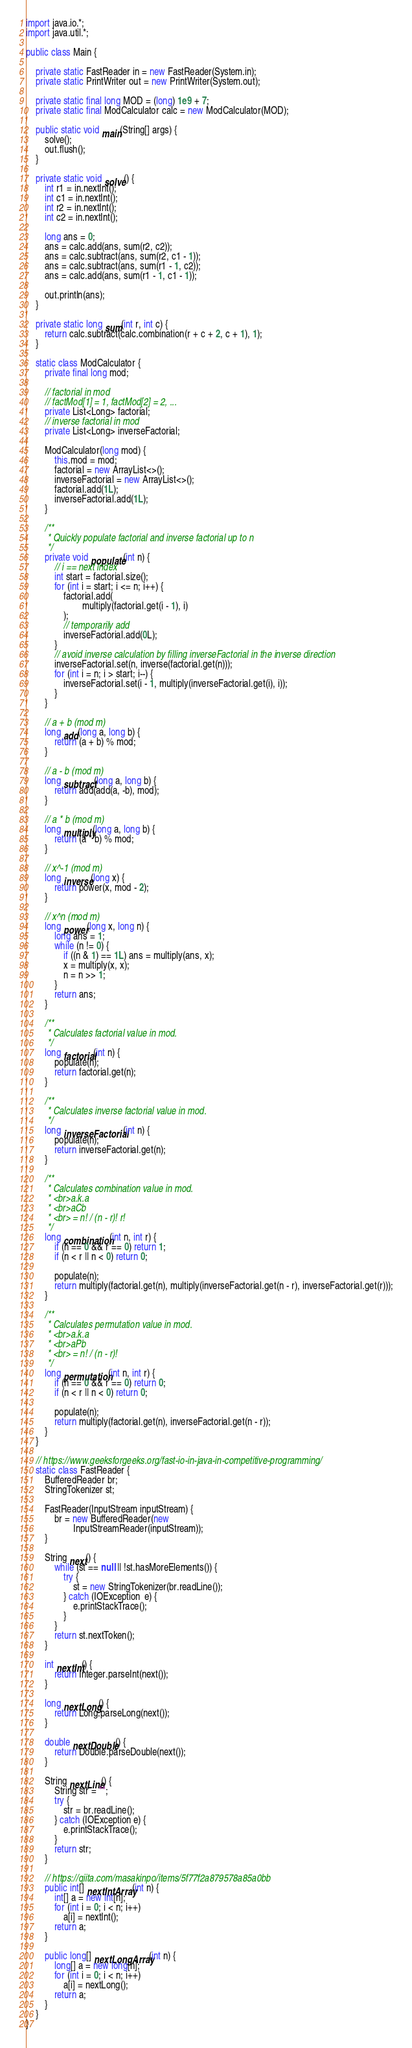Convert code to text. <code><loc_0><loc_0><loc_500><loc_500><_Java_>import java.io.*;
import java.util.*;

public class Main {

    private static FastReader in = new FastReader(System.in);
    private static PrintWriter out = new PrintWriter(System.out);

    private static final long MOD = (long) 1e9 + 7;
    private static final ModCalculator calc = new ModCalculator(MOD);

    public static void main(String[] args) {
        solve();
        out.flush();
    }

    private static void solve() {
        int r1 = in.nextInt();
        int c1 = in.nextInt();
        int r2 = in.nextInt();
        int c2 = in.nextInt();

        long ans = 0;
        ans = calc.add(ans, sum(r2, c2));
        ans = calc.subtract(ans, sum(r2, c1 - 1));
        ans = calc.subtract(ans, sum(r1 - 1, c2));
        ans = calc.add(ans, sum(r1 - 1, c1 - 1));

        out.println(ans);
    }

    private static long sum(int r, int c) {
        return calc.subtract(calc.combination(r + c + 2, c + 1), 1);
    }

    static class ModCalculator {
        private final long mod;

        // factorial in mod
        // factMod[1] = 1, factMod[2] = 2, ...
        private List<Long> factorial;
        // inverse factorial in mod
        private List<Long> inverseFactorial;

        ModCalculator(long mod) {
            this.mod = mod;
            factorial = new ArrayList<>();
            inverseFactorial = new ArrayList<>();
            factorial.add(1L);
            inverseFactorial.add(1L);
        }

        /**
         * Quickly populate factorial and inverse factorial up to n
         */
        private void populate(int n) {
            // i == next index
            int start = factorial.size();
            for (int i = start; i <= n; i++) {
                factorial.add(
                        multiply(factorial.get(i - 1), i)
                );
                // temporarily add
                inverseFactorial.add(0L);
            }
            // avoid inverse calculation by filling inverseFactorial in the inverse direction
            inverseFactorial.set(n, inverse(factorial.get(n)));
            for (int i = n; i > start; i--) {
                inverseFactorial.set(i - 1, multiply(inverseFactorial.get(i), i));
            }
        }

        // a + b (mod m)
        long add(long a, long b) {
            return (a + b) % mod;
        }

        // a - b (mod m)
        long subtract(long a, long b) {
            return add(add(a, -b), mod);
        }

        // a * b (mod m)
        long multiply(long a, long b) {
            return (a * b) % mod;
        }

        // x^-1 (mod m)
        long inverse(long x) {
            return power(x, mod - 2);
        }

        // x^n (mod m)
        long power(long x, long n) {
            long ans = 1;
            while (n != 0) {
                if ((n & 1) == 1L) ans = multiply(ans, x);
                x = multiply(x, x);
                n = n >> 1;
            }
            return ans;
        }

        /**
         * Calculates factorial value in mod.
         */
        long factorial(int n) {
            populate(n);
            return factorial.get(n);
        }

        /**
         * Calculates inverse factorial value in mod.
         */
        long inverseFactorial(int n) {
            populate(n);
            return inverseFactorial.get(n);
        }

        /**
         * Calculates combination value in mod.
         * <br>a.k.a
         * <br>aCb
         * <br> = n! / (n - r)! r!
         */
        long combination(int n, int r) {
            if (n == 0 && r == 0) return 1;
            if (n < r || n < 0) return 0;

            populate(n);
            return multiply(factorial.get(n), multiply(inverseFactorial.get(n - r), inverseFactorial.get(r)));
        }

        /**
         * Calculates permutation value in mod.
         * <br>a.k.a
         * <br>aPb
         * <br> = n! / (n - r)!
         */
        long permutation(int n, int r) {
            if (n == 0 && r == 0) return 0;
            if (n < r || n < 0) return 0;

            populate(n);
            return multiply(factorial.get(n), inverseFactorial.get(n - r));
        }
    }

    // https://www.geeksforgeeks.org/fast-io-in-java-in-competitive-programming/
    static class FastReader {
        BufferedReader br;
        StringTokenizer st;

        FastReader(InputStream inputStream) {
            br = new BufferedReader(new
                    InputStreamReader(inputStream));
        }

        String next() {
            while (st == null || !st.hasMoreElements()) {
                try {
                    st = new StringTokenizer(br.readLine());
                } catch (IOException  e) {
                    e.printStackTrace();
                }
            }
            return st.nextToken();
        }

        int nextInt() {
            return Integer.parseInt(next());
        }

        long nextLong() {
            return Long.parseLong(next());
        }

        double nextDouble() {
            return Double.parseDouble(next());
        }

        String nextLine() {
            String str = "";
            try {
                str = br.readLine();
            } catch (IOException e) {
                e.printStackTrace();
            }
            return str;
        }

        // https://qiita.com/masakinpo/items/5f77f2a879578a85a0bb
        public int[] nextIntArray(int n) {
            int[] a = new int[n];
            for (int i = 0; i < n; i++)
                a[i] = nextInt();
            return a;
        }

        public long[] nextLongArray(int n) {
            long[] a = new long[n];
            for (int i = 0; i < n; i++)
                a[i] = nextLong();
            return a;
        }
    }
}
</code> 